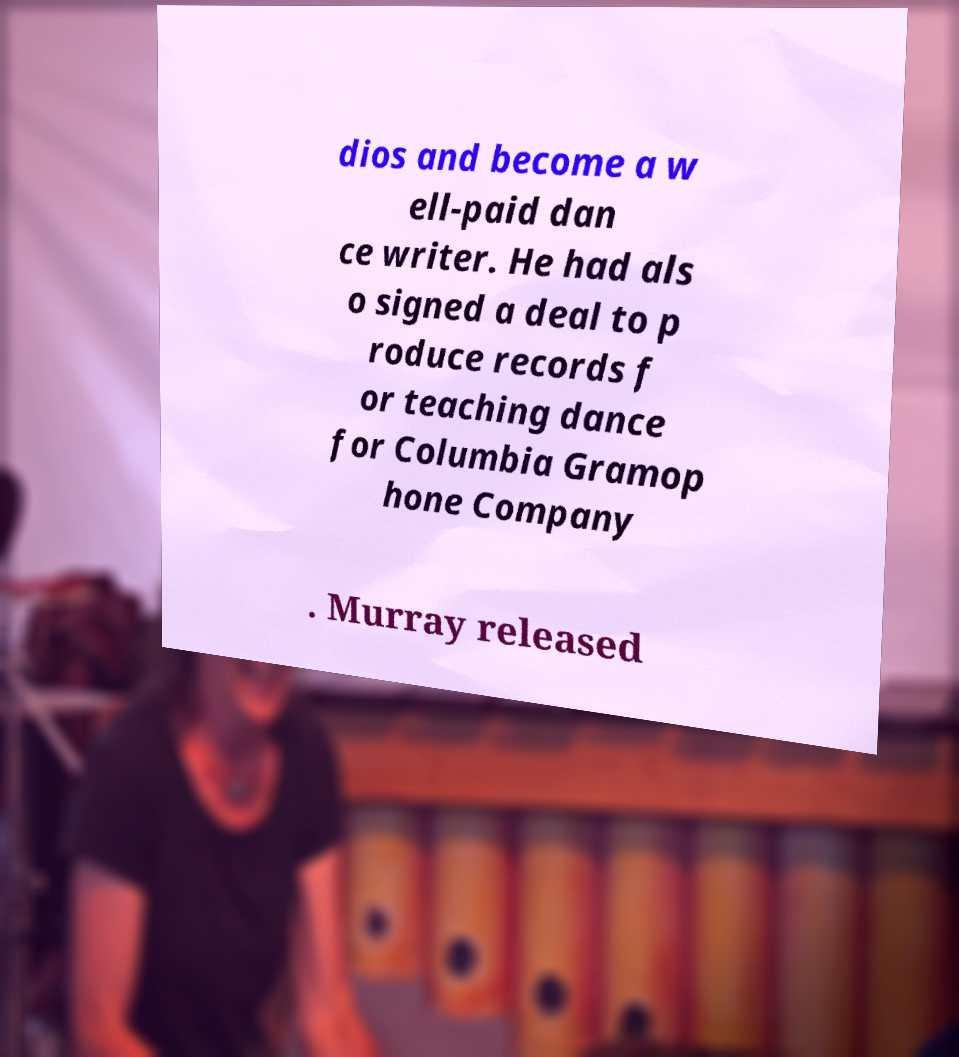Please identify and transcribe the text found in this image. dios and become a w ell-paid dan ce writer. He had als o signed a deal to p roduce records f or teaching dance for Columbia Gramop hone Company . Murray released 